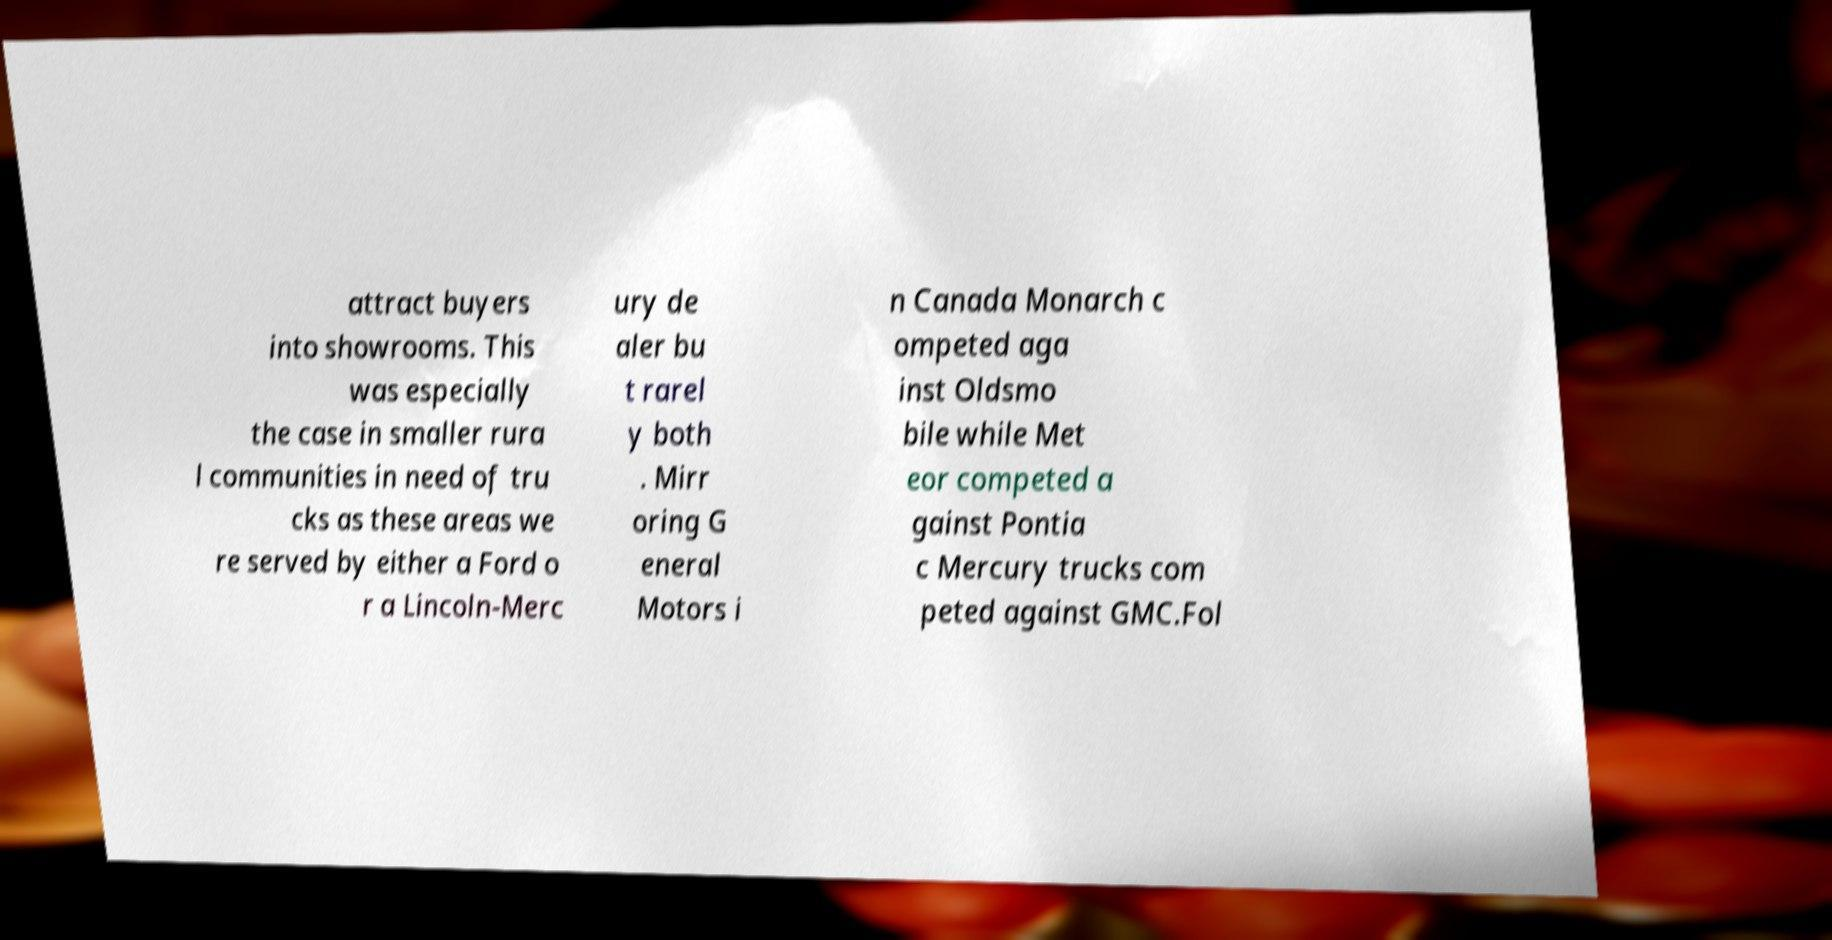Please identify and transcribe the text found in this image. attract buyers into showrooms. This was especially the case in smaller rura l communities in need of tru cks as these areas we re served by either a Ford o r a Lincoln-Merc ury de aler bu t rarel y both . Mirr oring G eneral Motors i n Canada Monarch c ompeted aga inst Oldsmo bile while Met eor competed a gainst Pontia c Mercury trucks com peted against GMC.Fol 